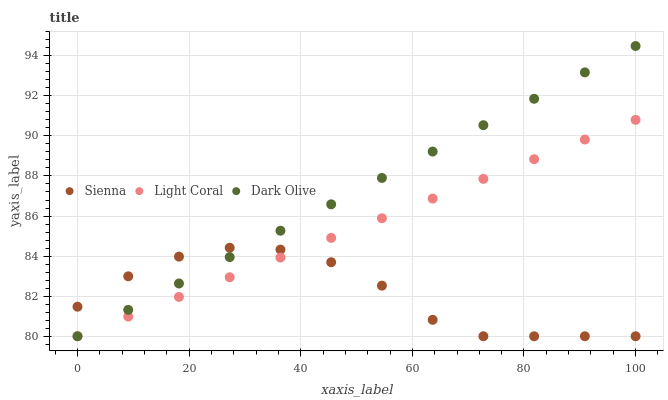Does Sienna have the minimum area under the curve?
Answer yes or no. Yes. Does Dark Olive have the maximum area under the curve?
Answer yes or no. Yes. Does Light Coral have the minimum area under the curve?
Answer yes or no. No. Does Light Coral have the maximum area under the curve?
Answer yes or no. No. Is Light Coral the smoothest?
Answer yes or no. Yes. Is Sienna the roughest?
Answer yes or no. Yes. Is Dark Olive the smoothest?
Answer yes or no. No. Is Dark Olive the roughest?
Answer yes or no. No. Does Sienna have the lowest value?
Answer yes or no. Yes. Does Dark Olive have the highest value?
Answer yes or no. Yes. Does Light Coral have the highest value?
Answer yes or no. No. Does Sienna intersect Light Coral?
Answer yes or no. Yes. Is Sienna less than Light Coral?
Answer yes or no. No. Is Sienna greater than Light Coral?
Answer yes or no. No. 